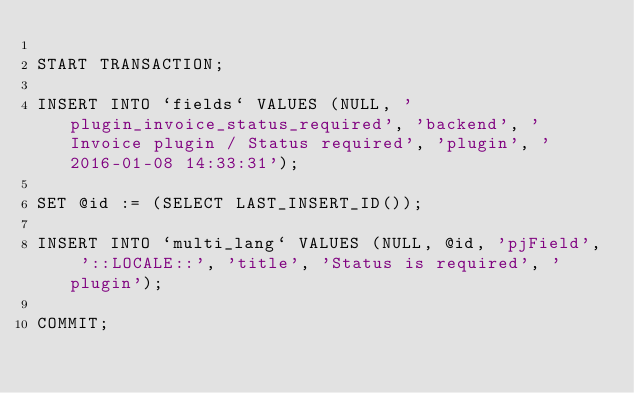Convert code to text. <code><loc_0><loc_0><loc_500><loc_500><_SQL_>
START TRANSACTION;

INSERT INTO `fields` VALUES (NULL, 'plugin_invoice_status_required', 'backend', 'Invoice plugin / Status required', 'plugin', '2016-01-08 14:33:31');

SET @id := (SELECT LAST_INSERT_ID());

INSERT INTO `multi_lang` VALUES (NULL, @id, 'pjField', '::LOCALE::', 'title', 'Status is required', 'plugin');

COMMIT;</code> 